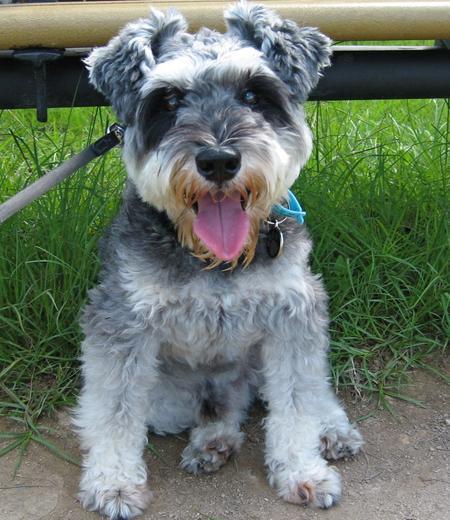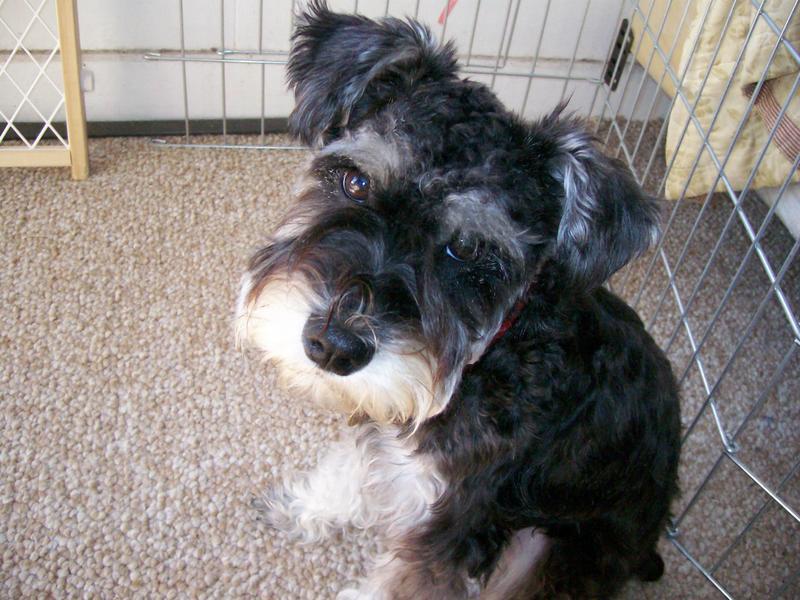The first image is the image on the left, the second image is the image on the right. Given the left and right images, does the statement "An image shows two schnauzers of similar size and coloring posed side-by-side." hold true? Answer yes or no. No. The first image is the image on the left, the second image is the image on the right. For the images displayed, is the sentence "At least one dog is showing its tongue." factually correct? Answer yes or no. Yes. 